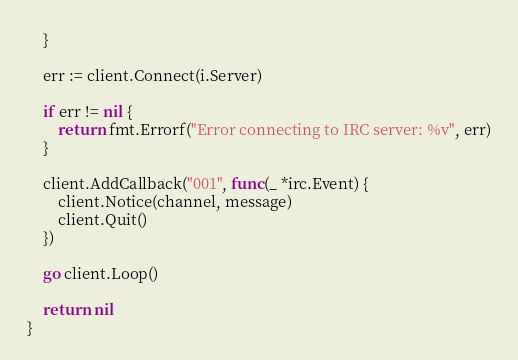Convert code to text. <code><loc_0><loc_0><loc_500><loc_500><_Go_>	}

	err := client.Connect(i.Server)

	if err != nil {
		return fmt.Errorf("Error connecting to IRC server: %v", err)
	}

	client.AddCallback("001", func(_ *irc.Event) {
		client.Notice(channel, message)
		client.Quit()
	})

	go client.Loop()

	return nil
}
</code> 